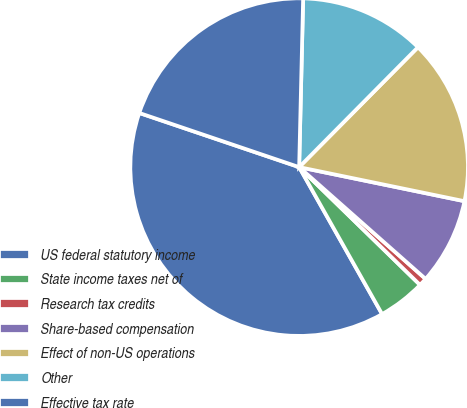Convert chart. <chart><loc_0><loc_0><loc_500><loc_500><pie_chart><fcel>US federal statutory income<fcel>State income taxes net of<fcel>Research tax credits<fcel>Share-based compensation<fcel>Effect of non-US operations<fcel>Other<fcel>Effective tax rate<nl><fcel>38.38%<fcel>4.53%<fcel>0.77%<fcel>8.29%<fcel>15.81%<fcel>12.05%<fcel>20.18%<nl></chart> 